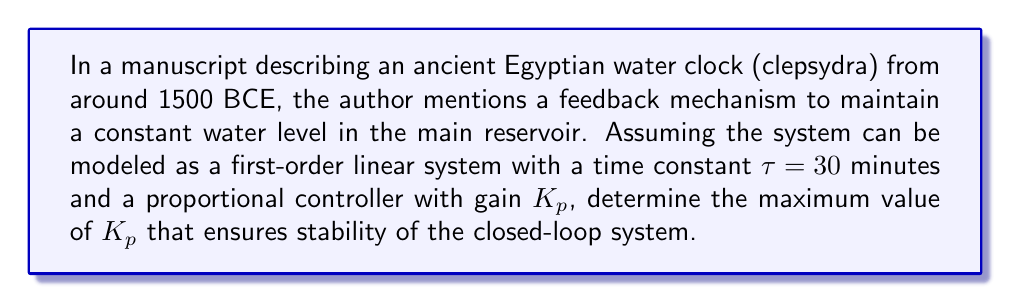Teach me how to tackle this problem. To analyze the stability of this ancient water clock system using control theory principles, we can follow these steps:

1. Model the system:
   The water clock can be represented as a first-order system with transfer function:
   
   $$G(s) = \frac{1}{\tau s + 1} = \frac{1}{30s + 1}$$

2. Add the proportional controller:
   The controller has a transfer function $C(s) = K_p$

3. Determine the closed-loop transfer function:
   $$T(s) = \frac{G(s)C(s)}{1 + G(s)C(s)} = \frac{K_p}{30s + 1 + K_p}$$

4. Analyze stability using the characteristic equation:
   The characteristic equation is the denominator of T(s) set to zero:
   
   $$30s + 1 + K_p = 0$$

5. Apply the Routh-Hurwitz stability criterion:
   For a first-order system, stability is ensured when all coefficients of the characteristic equation are positive. Therefore:
   
   $$30 > 0$$ (always true)
   $$1 + K_p > 0$$

6. Solve for the stability condition:
   $$1 + K_p > 0$$
   $$K_p > -1$$

Therefore, the maximum value of $K_p$ that ensures stability is any value greater than -1. Since gain is typically positive in practical systems, we can conclude that any positive value of $K_p$ will ensure stability of this ancient water clock system.
Answer: The maximum value of $K_p$ that ensures stability is any positive value, i.e., $K_p > 0$. 